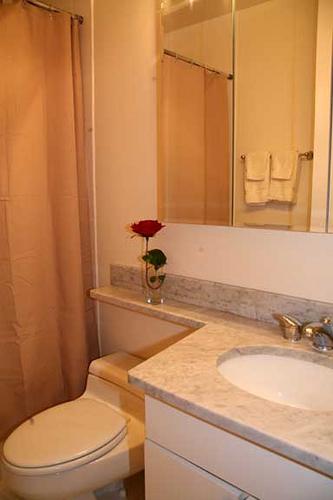What is on the counter?
Write a very short answer. Flower. What is the cabinet made of?
Be succinct. Wood. Are the people who live here slobs?
Give a very brief answer. No. What color is the room decorated?
Quick response, please. White. 